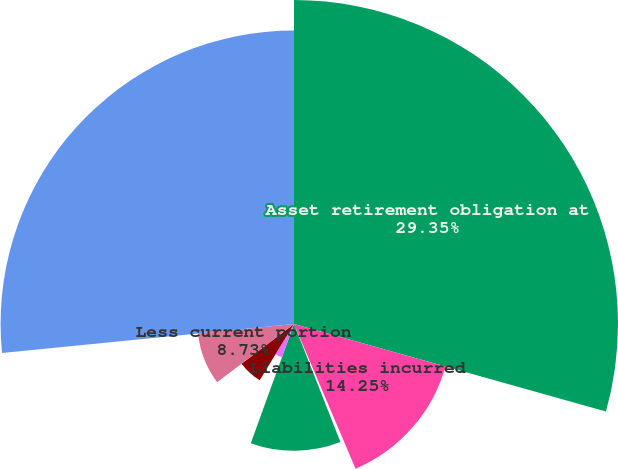Convert chart to OTSL. <chart><loc_0><loc_0><loc_500><loc_500><pie_chart><fcel>Asset retirement obligation at<fcel>Liabilities incurred<fcel>Liabilities acquired<fcel>Liabilities settled<fcel>Accretion expense<fcel>Revisions in estimated<fcel>Less current portion<fcel>Asset retirement obligation<nl><fcel>29.35%<fcel>14.25%<fcel>0.44%<fcel>11.49%<fcel>3.2%<fcel>5.96%<fcel>8.73%<fcel>26.58%<nl></chart> 